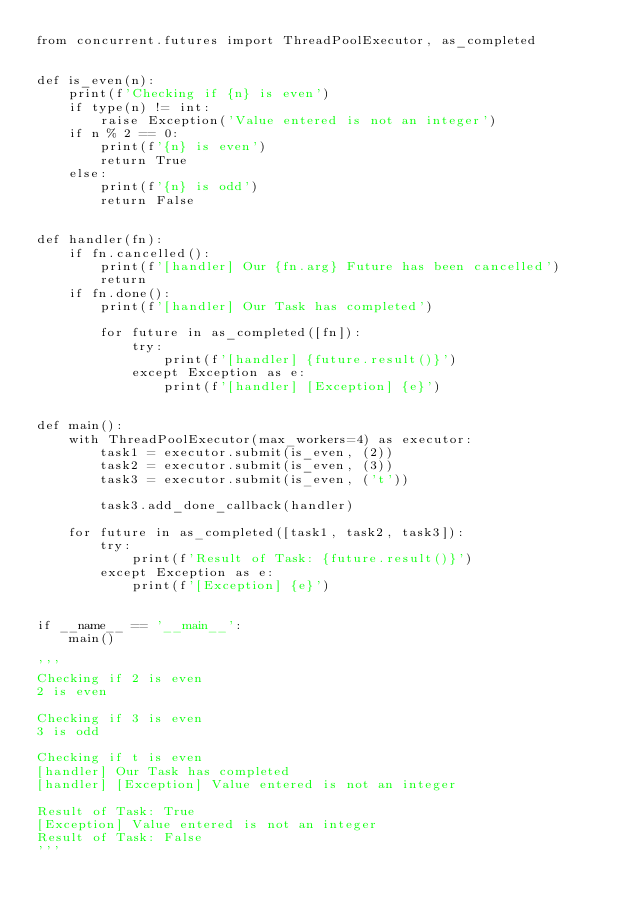<code> <loc_0><loc_0><loc_500><loc_500><_Python_>from concurrent.futures import ThreadPoolExecutor, as_completed


def is_even(n):
    print(f'Checking if {n} is even')
    if type(n) != int:
        raise Exception('Value entered is not an integer')
    if n % 2 == 0:
        print(f'{n} is even')
        return True
    else:
        print(f'{n} is odd')
        return False


def handler(fn):
    if fn.cancelled():
        print(f'[handler] Our {fn.arg} Future has been cancelled')
        return
    if fn.done():
        print(f'[handler] Our Task has completed')

        for future in as_completed([fn]):
            try:
                print(f'[handler] {future.result()}')
            except Exception as e:
                print(f'[handler] [Exception] {e}')


def main():
    with ThreadPoolExecutor(max_workers=4) as executor:
        task1 = executor.submit(is_even, (2))
        task2 = executor.submit(is_even, (3))
        task3 = executor.submit(is_even, ('t'))

        task3.add_done_callback(handler)

    for future in as_completed([task1, task2, task3]):
        try:
            print(f'Result of Task: {future.result()}')
        except Exception as e:
            print(f'[Exception] {e}')


if __name__ == '__main__':
    main()

'''
Checking if 2 is even
2 is even

Checking if 3 is even
3 is odd

Checking if t is even
[handler] Our Task has completed
[handler] [Exception] Value entered is not an integer

Result of Task: True
[Exception] Value entered is not an integer
Result of Task: False
'''
</code> 